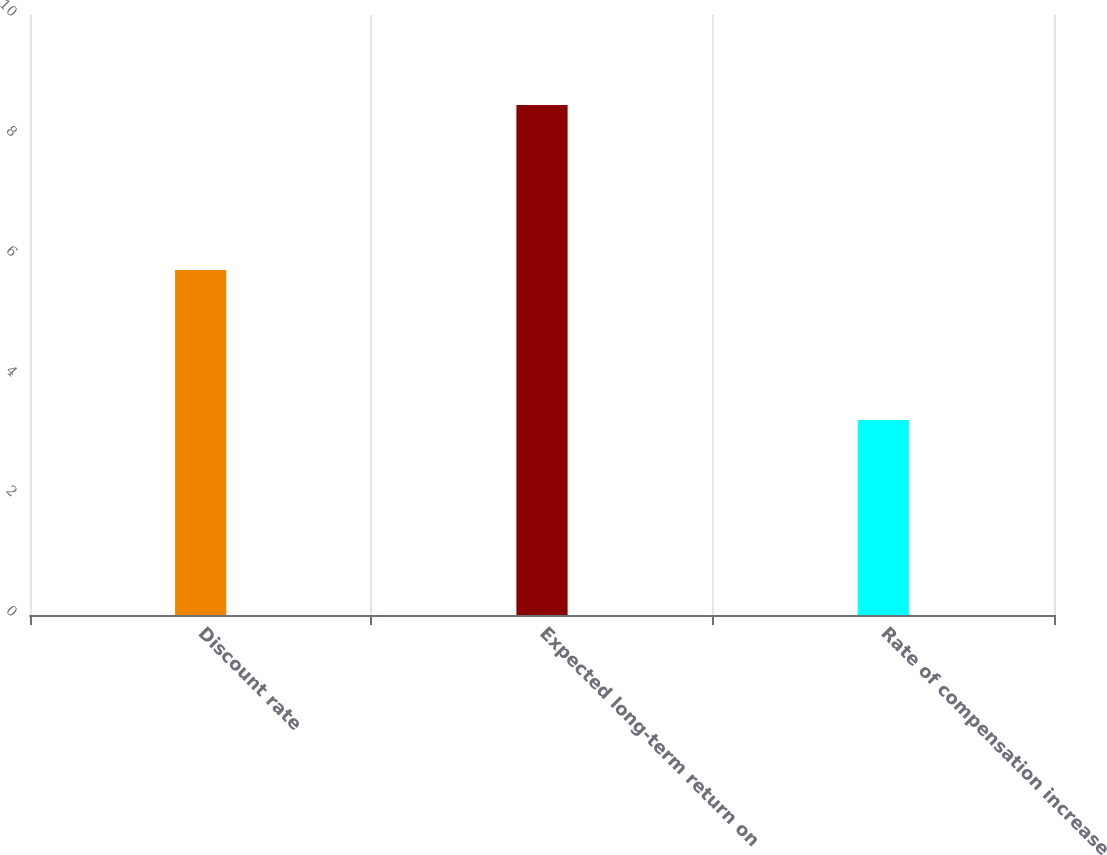Convert chart to OTSL. <chart><loc_0><loc_0><loc_500><loc_500><bar_chart><fcel>Discount rate<fcel>Expected long-term return on<fcel>Rate of compensation increase<nl><fcel>5.75<fcel>8.5<fcel>3.25<nl></chart> 